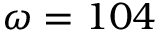Convert formula to latex. <formula><loc_0><loc_0><loc_500><loc_500>\omega = 1 0 4</formula> 